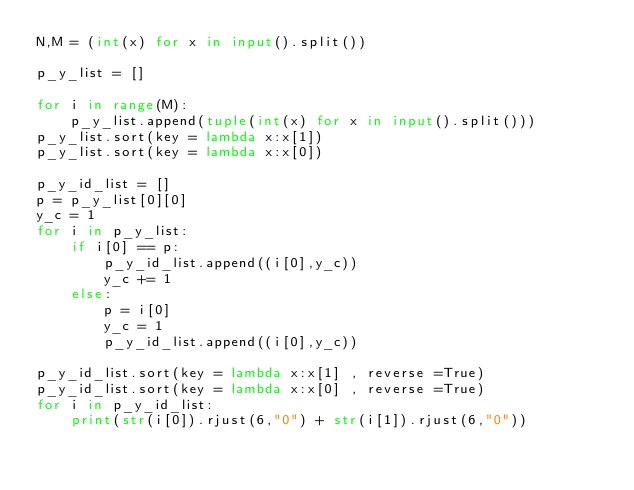Convert code to text. <code><loc_0><loc_0><loc_500><loc_500><_Python_>N,M = (int(x) for x in input().split())

p_y_list = []

for i in range(M):
    p_y_list.append(tuple(int(x) for x in input().split()))
p_y_list.sort(key = lambda x:x[1])
p_y_list.sort(key = lambda x:x[0])

p_y_id_list = []
p = p_y_list[0][0]
y_c = 1
for i in p_y_list:
    if i[0] == p:
        p_y_id_list.append((i[0],y_c))
        y_c += 1
    else:
        p = i[0]
        y_c = 1
        p_y_id_list.append((i[0],y_c))

p_y_id_list.sort(key = lambda x:x[1] , reverse =True)
p_y_id_list.sort(key = lambda x:x[0] , reverse =True)
for i in p_y_id_list:
    print(str(i[0]).rjust(6,"0") + str(i[1]).rjust(6,"0"))</code> 